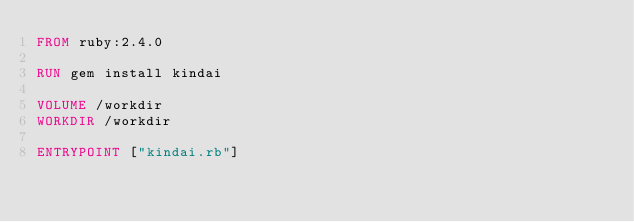<code> <loc_0><loc_0><loc_500><loc_500><_Dockerfile_>FROM ruby:2.4.0

RUN gem install kindai

VOLUME /workdir
WORKDIR /workdir

ENTRYPOINT ["kindai.rb"]
</code> 